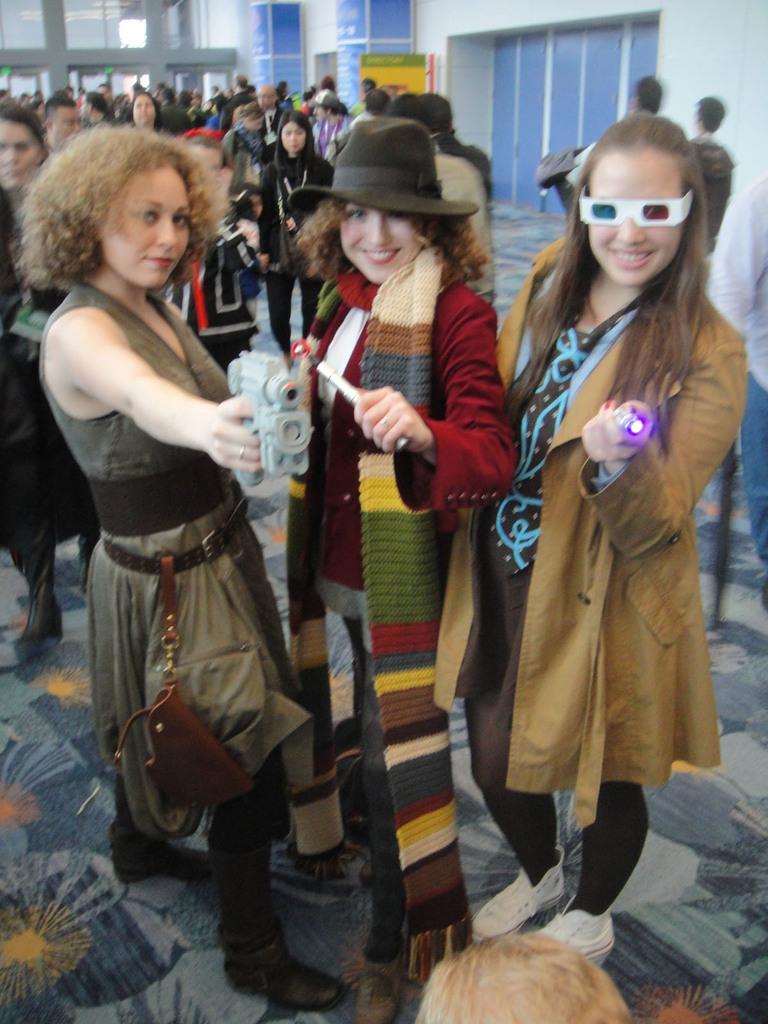Describe this image in one or two sentences. In this image I, in the foreground there are three girls looking at someone, and at the back there are many people standing. 